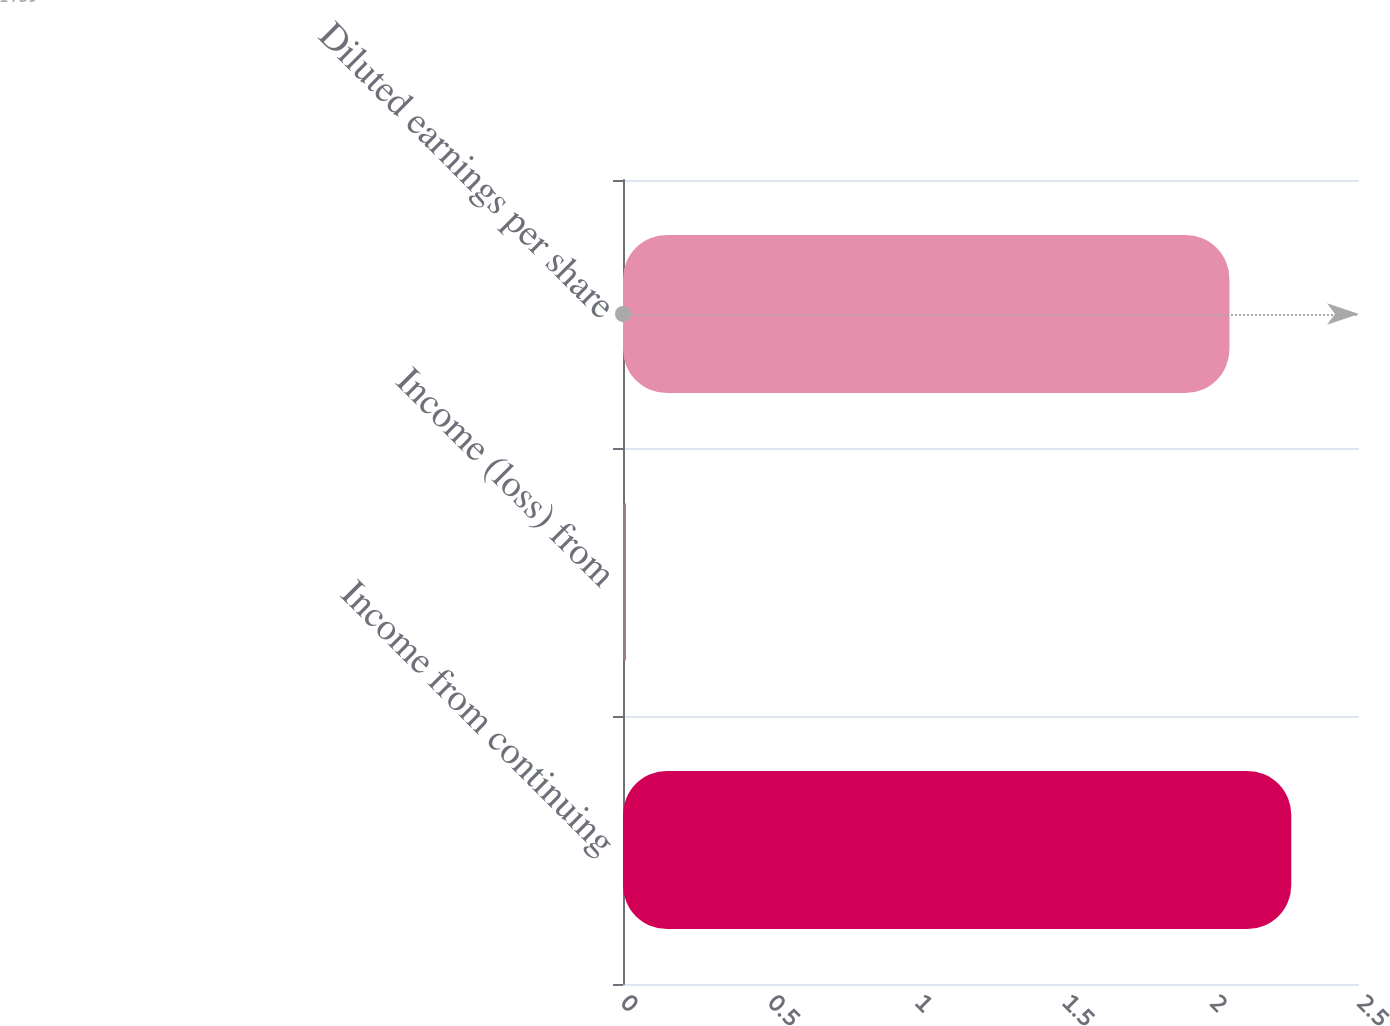Convert chart to OTSL. <chart><loc_0><loc_0><loc_500><loc_500><bar_chart><fcel>Income from continuing<fcel>Income (loss) from<fcel>Diluted earnings per share<nl><fcel>2.27<fcel>0.01<fcel>2.06<nl></chart> 